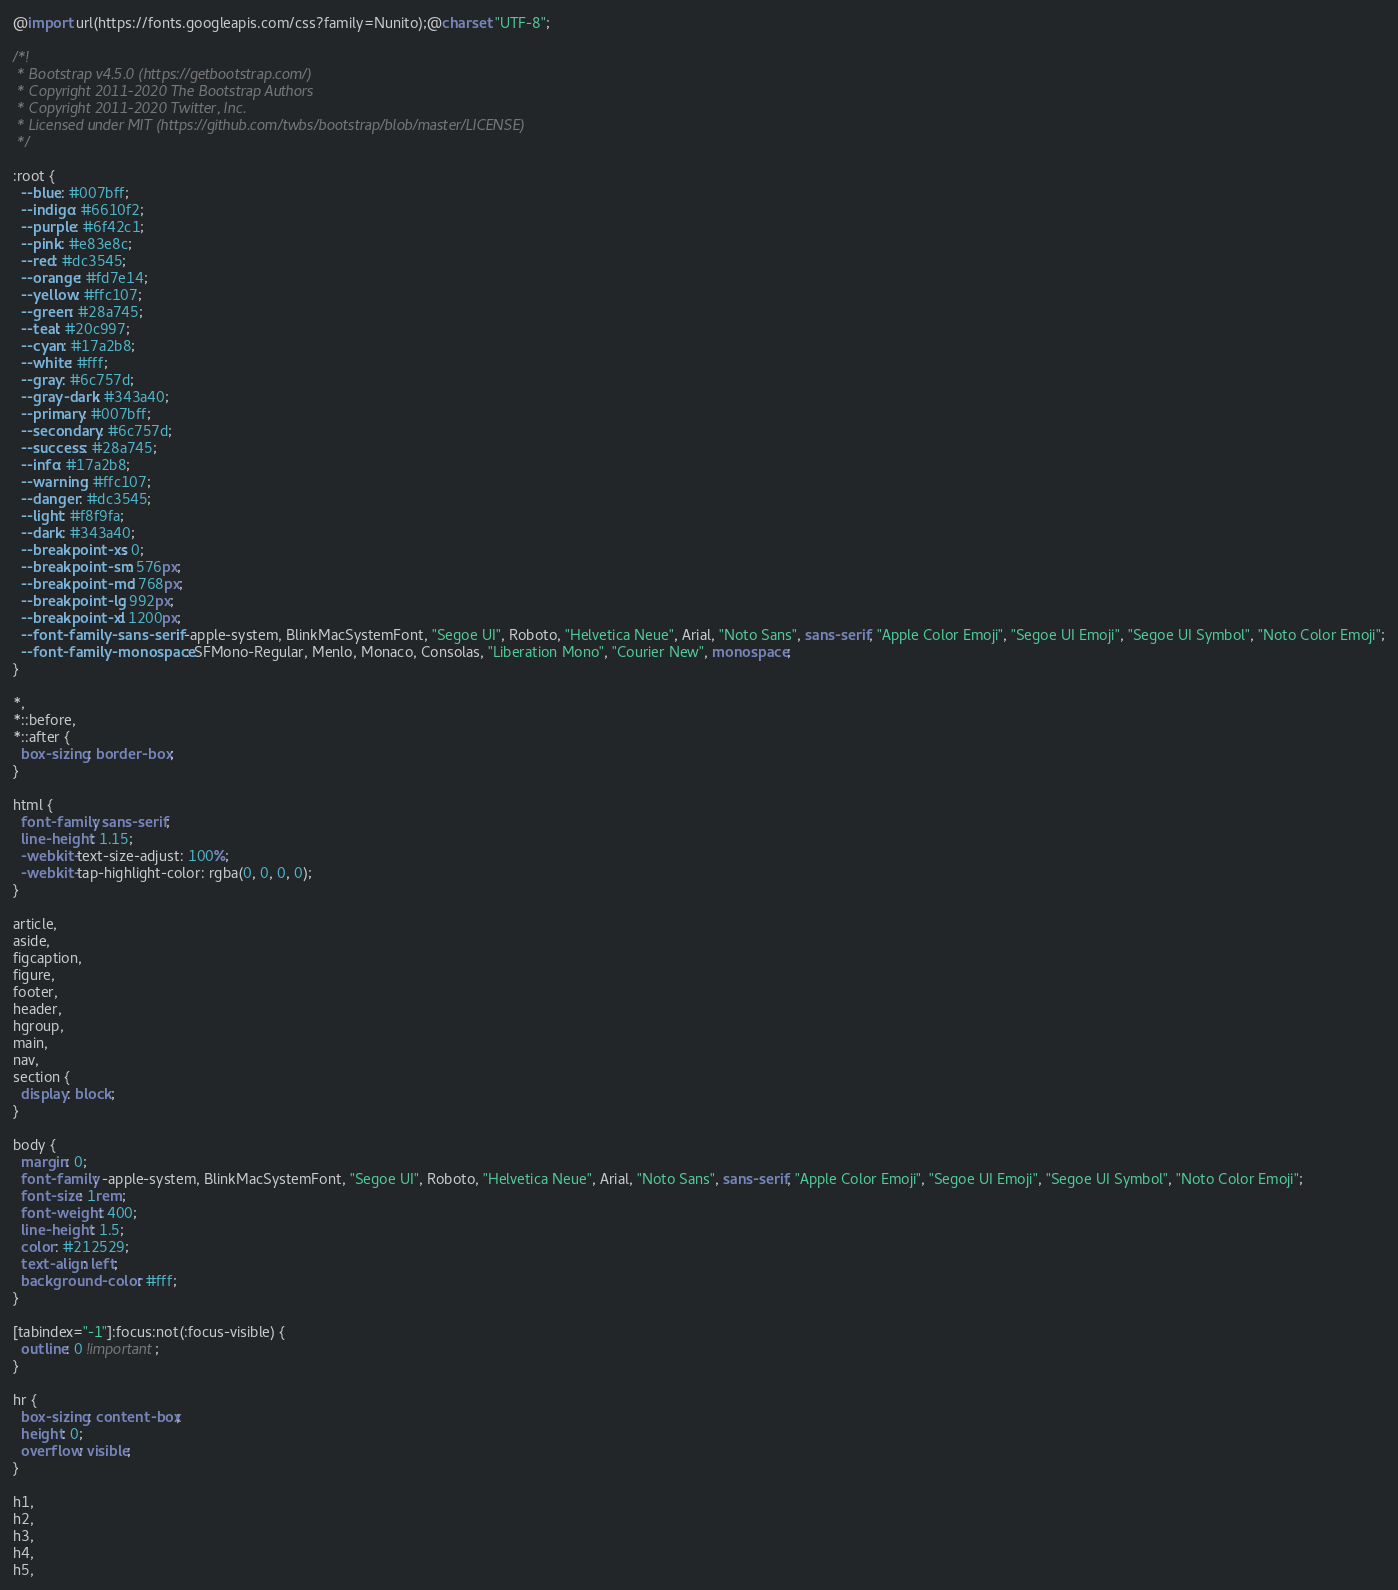<code> <loc_0><loc_0><loc_500><loc_500><_CSS_>@import url(https://fonts.googleapis.com/css?family=Nunito);@charset "UTF-8";

/*!
 * Bootstrap v4.5.0 (https://getbootstrap.com/)
 * Copyright 2011-2020 The Bootstrap Authors
 * Copyright 2011-2020 Twitter, Inc.
 * Licensed under MIT (https://github.com/twbs/bootstrap/blob/master/LICENSE)
 */

:root {
  --blue: #007bff;
  --indigo: #6610f2;
  --purple: #6f42c1;
  --pink: #e83e8c;
  --red: #dc3545;
  --orange: #fd7e14;
  --yellow: #ffc107;
  --green: #28a745;
  --teal: #20c997;
  --cyan: #17a2b8;
  --white: #fff;
  --gray: #6c757d;
  --gray-dark: #343a40;
  --primary: #007bff;
  --secondary: #6c757d;
  --success: #28a745;
  --info: #17a2b8;
  --warning: #ffc107;
  --danger: #dc3545;
  --light: #f8f9fa;
  --dark: #343a40;
  --breakpoint-xs: 0;
  --breakpoint-sm: 576px;
  --breakpoint-md: 768px;
  --breakpoint-lg: 992px;
  --breakpoint-xl: 1200px;
  --font-family-sans-serif: -apple-system, BlinkMacSystemFont, "Segoe UI", Roboto, "Helvetica Neue", Arial, "Noto Sans", sans-serif, "Apple Color Emoji", "Segoe UI Emoji", "Segoe UI Symbol", "Noto Color Emoji";
  --font-family-monospace: SFMono-Regular, Menlo, Monaco, Consolas, "Liberation Mono", "Courier New", monospace;
}

*,
*::before,
*::after {
  box-sizing: border-box;
}

html {
  font-family: sans-serif;
  line-height: 1.15;
  -webkit-text-size-adjust: 100%;
  -webkit-tap-highlight-color: rgba(0, 0, 0, 0);
}

article,
aside,
figcaption,
figure,
footer,
header,
hgroup,
main,
nav,
section {
  display: block;
}

body {
  margin: 0;
  font-family: -apple-system, BlinkMacSystemFont, "Segoe UI", Roboto, "Helvetica Neue", Arial, "Noto Sans", sans-serif, "Apple Color Emoji", "Segoe UI Emoji", "Segoe UI Symbol", "Noto Color Emoji";
  font-size: 1rem;
  font-weight: 400;
  line-height: 1.5;
  color: #212529;
  text-align: left;
  background-color: #fff;
}

[tabindex="-1"]:focus:not(:focus-visible) {
  outline: 0 !important;
}

hr {
  box-sizing: content-box;
  height: 0;
  overflow: visible;
}

h1,
h2,
h3,
h4,
h5,</code> 